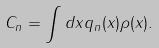<formula> <loc_0><loc_0><loc_500><loc_500>C _ { n } = \int d x q _ { n } ( x ) \rho ( x ) .</formula> 